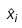<formula> <loc_0><loc_0><loc_500><loc_500>\hat { x } _ { i }</formula> 